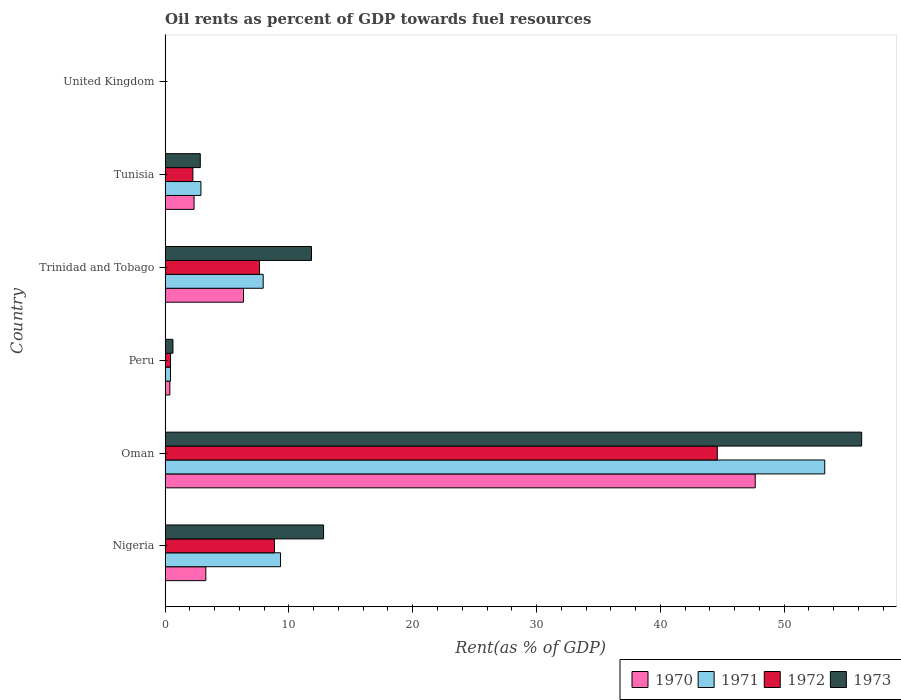How many different coloured bars are there?
Your response must be concise. 4. Are the number of bars per tick equal to the number of legend labels?
Your answer should be very brief. Yes. Are the number of bars on each tick of the Y-axis equal?
Provide a succinct answer. Yes. How many bars are there on the 1st tick from the bottom?
Keep it short and to the point. 4. What is the label of the 6th group of bars from the top?
Your answer should be compact. Nigeria. What is the oil rent in 1971 in Trinidad and Tobago?
Offer a terse response. 7.92. Across all countries, what is the maximum oil rent in 1970?
Give a very brief answer. 47.66. Across all countries, what is the minimum oil rent in 1973?
Offer a very short reply. 0. In which country was the oil rent in 1973 maximum?
Ensure brevity in your answer.  Oman. In which country was the oil rent in 1973 minimum?
Provide a short and direct response. United Kingdom. What is the total oil rent in 1972 in the graph?
Your answer should be compact. 63.74. What is the difference between the oil rent in 1973 in Peru and that in United Kingdom?
Provide a short and direct response. 0.63. What is the difference between the oil rent in 1971 in Tunisia and the oil rent in 1970 in Oman?
Provide a short and direct response. -44.77. What is the average oil rent in 1971 per country?
Make the answer very short. 12.31. What is the difference between the oil rent in 1973 and oil rent in 1970 in Trinidad and Tobago?
Offer a terse response. 5.49. What is the ratio of the oil rent in 1971 in Nigeria to that in Tunisia?
Provide a succinct answer. 3.22. What is the difference between the highest and the second highest oil rent in 1972?
Provide a short and direct response. 35.77. What is the difference between the highest and the lowest oil rent in 1972?
Your response must be concise. 44.6. In how many countries, is the oil rent in 1971 greater than the average oil rent in 1971 taken over all countries?
Keep it short and to the point. 1. Is it the case that in every country, the sum of the oil rent in 1973 and oil rent in 1972 is greater than the sum of oil rent in 1970 and oil rent in 1971?
Provide a short and direct response. No. What does the 1st bar from the top in Trinidad and Tobago represents?
Provide a short and direct response. 1973. Is it the case that in every country, the sum of the oil rent in 1970 and oil rent in 1973 is greater than the oil rent in 1972?
Provide a short and direct response. Yes. Are all the bars in the graph horizontal?
Offer a terse response. Yes. How many countries are there in the graph?
Make the answer very short. 6. Are the values on the major ticks of X-axis written in scientific E-notation?
Offer a very short reply. No. How are the legend labels stacked?
Provide a succinct answer. Horizontal. What is the title of the graph?
Offer a very short reply. Oil rents as percent of GDP towards fuel resources. Does "1972" appear as one of the legend labels in the graph?
Your answer should be compact. Yes. What is the label or title of the X-axis?
Your answer should be very brief. Rent(as % of GDP). What is the label or title of the Y-axis?
Offer a very short reply. Country. What is the Rent(as % of GDP) of 1970 in Nigeria?
Your answer should be very brief. 3.29. What is the Rent(as % of GDP) in 1971 in Nigeria?
Make the answer very short. 9.32. What is the Rent(as % of GDP) of 1972 in Nigeria?
Your response must be concise. 8.83. What is the Rent(as % of GDP) of 1973 in Nigeria?
Give a very brief answer. 12.8. What is the Rent(as % of GDP) in 1970 in Oman?
Keep it short and to the point. 47.66. What is the Rent(as % of GDP) of 1971 in Oman?
Your answer should be compact. 53.28. What is the Rent(as % of GDP) of 1972 in Oman?
Keep it short and to the point. 44.6. What is the Rent(as % of GDP) of 1973 in Oman?
Keep it short and to the point. 56.26. What is the Rent(as % of GDP) in 1970 in Peru?
Provide a succinct answer. 0.39. What is the Rent(as % of GDP) in 1971 in Peru?
Make the answer very short. 0.44. What is the Rent(as % of GDP) in 1972 in Peru?
Your answer should be very brief. 0.44. What is the Rent(as % of GDP) of 1973 in Peru?
Keep it short and to the point. 0.64. What is the Rent(as % of GDP) of 1970 in Trinidad and Tobago?
Provide a succinct answer. 6.33. What is the Rent(as % of GDP) of 1971 in Trinidad and Tobago?
Ensure brevity in your answer.  7.92. What is the Rent(as % of GDP) of 1972 in Trinidad and Tobago?
Offer a terse response. 7.63. What is the Rent(as % of GDP) of 1973 in Trinidad and Tobago?
Provide a succinct answer. 11.82. What is the Rent(as % of GDP) of 1970 in Tunisia?
Offer a terse response. 2.34. What is the Rent(as % of GDP) in 1971 in Tunisia?
Give a very brief answer. 2.89. What is the Rent(as % of GDP) of 1972 in Tunisia?
Provide a short and direct response. 2.25. What is the Rent(as % of GDP) in 1973 in Tunisia?
Your response must be concise. 2.84. What is the Rent(as % of GDP) of 1970 in United Kingdom?
Keep it short and to the point. 0. What is the Rent(as % of GDP) in 1971 in United Kingdom?
Your response must be concise. 0. What is the Rent(as % of GDP) of 1972 in United Kingdom?
Offer a very short reply. 0. What is the Rent(as % of GDP) of 1973 in United Kingdom?
Offer a terse response. 0. Across all countries, what is the maximum Rent(as % of GDP) of 1970?
Your response must be concise. 47.66. Across all countries, what is the maximum Rent(as % of GDP) of 1971?
Provide a short and direct response. 53.28. Across all countries, what is the maximum Rent(as % of GDP) in 1972?
Make the answer very short. 44.6. Across all countries, what is the maximum Rent(as % of GDP) in 1973?
Offer a terse response. 56.26. Across all countries, what is the minimum Rent(as % of GDP) in 1970?
Keep it short and to the point. 0. Across all countries, what is the minimum Rent(as % of GDP) of 1971?
Keep it short and to the point. 0. Across all countries, what is the minimum Rent(as % of GDP) in 1972?
Your answer should be very brief. 0. Across all countries, what is the minimum Rent(as % of GDP) of 1973?
Offer a very short reply. 0. What is the total Rent(as % of GDP) in 1970 in the graph?
Your answer should be compact. 60.01. What is the total Rent(as % of GDP) in 1971 in the graph?
Provide a short and direct response. 73.85. What is the total Rent(as % of GDP) in 1972 in the graph?
Your answer should be very brief. 63.74. What is the total Rent(as % of GDP) in 1973 in the graph?
Your response must be concise. 84.36. What is the difference between the Rent(as % of GDP) of 1970 in Nigeria and that in Oman?
Your answer should be very brief. -44.37. What is the difference between the Rent(as % of GDP) in 1971 in Nigeria and that in Oman?
Provide a short and direct response. -43.95. What is the difference between the Rent(as % of GDP) in 1972 in Nigeria and that in Oman?
Your answer should be very brief. -35.77. What is the difference between the Rent(as % of GDP) of 1973 in Nigeria and that in Oman?
Provide a succinct answer. -43.46. What is the difference between the Rent(as % of GDP) of 1970 in Nigeria and that in Peru?
Provide a succinct answer. 2.9. What is the difference between the Rent(as % of GDP) in 1971 in Nigeria and that in Peru?
Keep it short and to the point. 8.89. What is the difference between the Rent(as % of GDP) of 1972 in Nigeria and that in Peru?
Make the answer very short. 8.39. What is the difference between the Rent(as % of GDP) in 1973 in Nigeria and that in Peru?
Keep it short and to the point. 12.16. What is the difference between the Rent(as % of GDP) in 1970 in Nigeria and that in Trinidad and Tobago?
Your answer should be very brief. -3.04. What is the difference between the Rent(as % of GDP) of 1971 in Nigeria and that in Trinidad and Tobago?
Offer a very short reply. 1.4. What is the difference between the Rent(as % of GDP) of 1972 in Nigeria and that in Trinidad and Tobago?
Your answer should be compact. 1.2. What is the difference between the Rent(as % of GDP) of 1973 in Nigeria and that in Trinidad and Tobago?
Your answer should be compact. 0.98. What is the difference between the Rent(as % of GDP) of 1970 in Nigeria and that in Tunisia?
Your response must be concise. 0.95. What is the difference between the Rent(as % of GDP) of 1971 in Nigeria and that in Tunisia?
Your answer should be compact. 6.43. What is the difference between the Rent(as % of GDP) in 1972 in Nigeria and that in Tunisia?
Your response must be concise. 6.58. What is the difference between the Rent(as % of GDP) of 1973 in Nigeria and that in Tunisia?
Make the answer very short. 9.96. What is the difference between the Rent(as % of GDP) of 1970 in Nigeria and that in United Kingdom?
Your answer should be compact. 3.29. What is the difference between the Rent(as % of GDP) of 1971 in Nigeria and that in United Kingdom?
Your answer should be very brief. 9.32. What is the difference between the Rent(as % of GDP) in 1972 in Nigeria and that in United Kingdom?
Provide a succinct answer. 8.83. What is the difference between the Rent(as % of GDP) of 1973 in Nigeria and that in United Kingdom?
Offer a terse response. 12.8. What is the difference between the Rent(as % of GDP) of 1970 in Oman and that in Peru?
Your answer should be very brief. 47.28. What is the difference between the Rent(as % of GDP) in 1971 in Oman and that in Peru?
Your answer should be very brief. 52.84. What is the difference between the Rent(as % of GDP) of 1972 in Oman and that in Peru?
Provide a short and direct response. 44.16. What is the difference between the Rent(as % of GDP) in 1973 in Oman and that in Peru?
Your answer should be very brief. 55.62. What is the difference between the Rent(as % of GDP) of 1970 in Oman and that in Trinidad and Tobago?
Ensure brevity in your answer.  41.33. What is the difference between the Rent(as % of GDP) of 1971 in Oman and that in Trinidad and Tobago?
Your answer should be compact. 45.35. What is the difference between the Rent(as % of GDP) of 1972 in Oman and that in Trinidad and Tobago?
Keep it short and to the point. 36.97. What is the difference between the Rent(as % of GDP) of 1973 in Oman and that in Trinidad and Tobago?
Provide a succinct answer. 44.44. What is the difference between the Rent(as % of GDP) in 1970 in Oman and that in Tunisia?
Your answer should be compact. 45.32. What is the difference between the Rent(as % of GDP) of 1971 in Oman and that in Tunisia?
Your answer should be compact. 50.38. What is the difference between the Rent(as % of GDP) of 1972 in Oman and that in Tunisia?
Offer a terse response. 42.36. What is the difference between the Rent(as % of GDP) in 1973 in Oman and that in Tunisia?
Provide a succinct answer. 53.42. What is the difference between the Rent(as % of GDP) of 1970 in Oman and that in United Kingdom?
Your answer should be compact. 47.66. What is the difference between the Rent(as % of GDP) in 1971 in Oman and that in United Kingdom?
Offer a terse response. 53.28. What is the difference between the Rent(as % of GDP) in 1972 in Oman and that in United Kingdom?
Provide a short and direct response. 44.6. What is the difference between the Rent(as % of GDP) in 1973 in Oman and that in United Kingdom?
Offer a terse response. 56.26. What is the difference between the Rent(as % of GDP) in 1970 in Peru and that in Trinidad and Tobago?
Your response must be concise. -5.95. What is the difference between the Rent(as % of GDP) of 1971 in Peru and that in Trinidad and Tobago?
Give a very brief answer. -7.49. What is the difference between the Rent(as % of GDP) in 1972 in Peru and that in Trinidad and Tobago?
Offer a terse response. -7.19. What is the difference between the Rent(as % of GDP) in 1973 in Peru and that in Trinidad and Tobago?
Give a very brief answer. -11.19. What is the difference between the Rent(as % of GDP) in 1970 in Peru and that in Tunisia?
Give a very brief answer. -1.95. What is the difference between the Rent(as % of GDP) in 1971 in Peru and that in Tunisia?
Offer a terse response. -2.46. What is the difference between the Rent(as % of GDP) in 1972 in Peru and that in Tunisia?
Provide a succinct answer. -1.81. What is the difference between the Rent(as % of GDP) of 1973 in Peru and that in Tunisia?
Keep it short and to the point. -2.21. What is the difference between the Rent(as % of GDP) of 1970 in Peru and that in United Kingdom?
Offer a very short reply. 0.38. What is the difference between the Rent(as % of GDP) of 1971 in Peru and that in United Kingdom?
Provide a short and direct response. 0.44. What is the difference between the Rent(as % of GDP) in 1972 in Peru and that in United Kingdom?
Give a very brief answer. 0.44. What is the difference between the Rent(as % of GDP) in 1973 in Peru and that in United Kingdom?
Your answer should be compact. 0.63. What is the difference between the Rent(as % of GDP) of 1970 in Trinidad and Tobago and that in Tunisia?
Your answer should be very brief. 3.99. What is the difference between the Rent(as % of GDP) of 1971 in Trinidad and Tobago and that in Tunisia?
Offer a terse response. 5.03. What is the difference between the Rent(as % of GDP) of 1972 in Trinidad and Tobago and that in Tunisia?
Provide a short and direct response. 5.38. What is the difference between the Rent(as % of GDP) of 1973 in Trinidad and Tobago and that in Tunisia?
Offer a very short reply. 8.98. What is the difference between the Rent(as % of GDP) of 1970 in Trinidad and Tobago and that in United Kingdom?
Your answer should be very brief. 6.33. What is the difference between the Rent(as % of GDP) of 1971 in Trinidad and Tobago and that in United Kingdom?
Offer a terse response. 7.92. What is the difference between the Rent(as % of GDP) in 1972 in Trinidad and Tobago and that in United Kingdom?
Your answer should be very brief. 7.62. What is the difference between the Rent(as % of GDP) in 1973 in Trinidad and Tobago and that in United Kingdom?
Your response must be concise. 11.82. What is the difference between the Rent(as % of GDP) of 1970 in Tunisia and that in United Kingdom?
Your answer should be compact. 2.34. What is the difference between the Rent(as % of GDP) in 1971 in Tunisia and that in United Kingdom?
Offer a terse response. 2.89. What is the difference between the Rent(as % of GDP) of 1972 in Tunisia and that in United Kingdom?
Provide a short and direct response. 2.24. What is the difference between the Rent(as % of GDP) in 1973 in Tunisia and that in United Kingdom?
Offer a very short reply. 2.84. What is the difference between the Rent(as % of GDP) of 1970 in Nigeria and the Rent(as % of GDP) of 1971 in Oman?
Give a very brief answer. -49.99. What is the difference between the Rent(as % of GDP) in 1970 in Nigeria and the Rent(as % of GDP) in 1972 in Oman?
Offer a very short reply. -41.31. What is the difference between the Rent(as % of GDP) of 1970 in Nigeria and the Rent(as % of GDP) of 1973 in Oman?
Your answer should be very brief. -52.97. What is the difference between the Rent(as % of GDP) of 1971 in Nigeria and the Rent(as % of GDP) of 1972 in Oman?
Your response must be concise. -35.28. What is the difference between the Rent(as % of GDP) of 1971 in Nigeria and the Rent(as % of GDP) of 1973 in Oman?
Your response must be concise. -46.94. What is the difference between the Rent(as % of GDP) in 1972 in Nigeria and the Rent(as % of GDP) in 1973 in Oman?
Your answer should be compact. -47.43. What is the difference between the Rent(as % of GDP) of 1970 in Nigeria and the Rent(as % of GDP) of 1971 in Peru?
Give a very brief answer. 2.85. What is the difference between the Rent(as % of GDP) of 1970 in Nigeria and the Rent(as % of GDP) of 1972 in Peru?
Make the answer very short. 2.85. What is the difference between the Rent(as % of GDP) in 1970 in Nigeria and the Rent(as % of GDP) in 1973 in Peru?
Ensure brevity in your answer.  2.65. What is the difference between the Rent(as % of GDP) in 1971 in Nigeria and the Rent(as % of GDP) in 1972 in Peru?
Provide a short and direct response. 8.88. What is the difference between the Rent(as % of GDP) of 1971 in Nigeria and the Rent(as % of GDP) of 1973 in Peru?
Provide a short and direct response. 8.69. What is the difference between the Rent(as % of GDP) of 1972 in Nigeria and the Rent(as % of GDP) of 1973 in Peru?
Provide a short and direct response. 8.19. What is the difference between the Rent(as % of GDP) in 1970 in Nigeria and the Rent(as % of GDP) in 1971 in Trinidad and Tobago?
Offer a very short reply. -4.63. What is the difference between the Rent(as % of GDP) in 1970 in Nigeria and the Rent(as % of GDP) in 1972 in Trinidad and Tobago?
Keep it short and to the point. -4.34. What is the difference between the Rent(as % of GDP) in 1970 in Nigeria and the Rent(as % of GDP) in 1973 in Trinidad and Tobago?
Your answer should be very brief. -8.53. What is the difference between the Rent(as % of GDP) of 1971 in Nigeria and the Rent(as % of GDP) of 1972 in Trinidad and Tobago?
Offer a terse response. 1.7. What is the difference between the Rent(as % of GDP) in 1971 in Nigeria and the Rent(as % of GDP) in 1973 in Trinidad and Tobago?
Give a very brief answer. -2.5. What is the difference between the Rent(as % of GDP) in 1972 in Nigeria and the Rent(as % of GDP) in 1973 in Trinidad and Tobago?
Ensure brevity in your answer.  -2.99. What is the difference between the Rent(as % of GDP) of 1970 in Nigeria and the Rent(as % of GDP) of 1971 in Tunisia?
Make the answer very short. 0.4. What is the difference between the Rent(as % of GDP) in 1970 in Nigeria and the Rent(as % of GDP) in 1972 in Tunisia?
Offer a very short reply. 1.04. What is the difference between the Rent(as % of GDP) of 1970 in Nigeria and the Rent(as % of GDP) of 1973 in Tunisia?
Give a very brief answer. 0.45. What is the difference between the Rent(as % of GDP) in 1971 in Nigeria and the Rent(as % of GDP) in 1972 in Tunisia?
Your answer should be very brief. 7.08. What is the difference between the Rent(as % of GDP) in 1971 in Nigeria and the Rent(as % of GDP) in 1973 in Tunisia?
Offer a terse response. 6.48. What is the difference between the Rent(as % of GDP) in 1972 in Nigeria and the Rent(as % of GDP) in 1973 in Tunisia?
Provide a short and direct response. 5.99. What is the difference between the Rent(as % of GDP) in 1970 in Nigeria and the Rent(as % of GDP) in 1971 in United Kingdom?
Your response must be concise. 3.29. What is the difference between the Rent(as % of GDP) of 1970 in Nigeria and the Rent(as % of GDP) of 1972 in United Kingdom?
Your answer should be compact. 3.29. What is the difference between the Rent(as % of GDP) in 1970 in Nigeria and the Rent(as % of GDP) in 1973 in United Kingdom?
Your response must be concise. 3.29. What is the difference between the Rent(as % of GDP) in 1971 in Nigeria and the Rent(as % of GDP) in 1972 in United Kingdom?
Provide a short and direct response. 9.32. What is the difference between the Rent(as % of GDP) of 1971 in Nigeria and the Rent(as % of GDP) of 1973 in United Kingdom?
Your response must be concise. 9.32. What is the difference between the Rent(as % of GDP) of 1972 in Nigeria and the Rent(as % of GDP) of 1973 in United Kingdom?
Your answer should be very brief. 8.83. What is the difference between the Rent(as % of GDP) of 1970 in Oman and the Rent(as % of GDP) of 1971 in Peru?
Your answer should be compact. 47.23. What is the difference between the Rent(as % of GDP) of 1970 in Oman and the Rent(as % of GDP) of 1972 in Peru?
Give a very brief answer. 47.22. What is the difference between the Rent(as % of GDP) in 1970 in Oman and the Rent(as % of GDP) in 1973 in Peru?
Your response must be concise. 47.03. What is the difference between the Rent(as % of GDP) in 1971 in Oman and the Rent(as % of GDP) in 1972 in Peru?
Keep it short and to the point. 52.84. What is the difference between the Rent(as % of GDP) of 1971 in Oman and the Rent(as % of GDP) of 1973 in Peru?
Ensure brevity in your answer.  52.64. What is the difference between the Rent(as % of GDP) of 1972 in Oman and the Rent(as % of GDP) of 1973 in Peru?
Keep it short and to the point. 43.96. What is the difference between the Rent(as % of GDP) of 1970 in Oman and the Rent(as % of GDP) of 1971 in Trinidad and Tobago?
Offer a terse response. 39.74. What is the difference between the Rent(as % of GDP) in 1970 in Oman and the Rent(as % of GDP) in 1972 in Trinidad and Tobago?
Offer a terse response. 40.04. What is the difference between the Rent(as % of GDP) in 1970 in Oman and the Rent(as % of GDP) in 1973 in Trinidad and Tobago?
Provide a succinct answer. 35.84. What is the difference between the Rent(as % of GDP) of 1971 in Oman and the Rent(as % of GDP) of 1972 in Trinidad and Tobago?
Offer a very short reply. 45.65. What is the difference between the Rent(as % of GDP) in 1971 in Oman and the Rent(as % of GDP) in 1973 in Trinidad and Tobago?
Your answer should be very brief. 41.45. What is the difference between the Rent(as % of GDP) of 1972 in Oman and the Rent(as % of GDP) of 1973 in Trinidad and Tobago?
Give a very brief answer. 32.78. What is the difference between the Rent(as % of GDP) of 1970 in Oman and the Rent(as % of GDP) of 1971 in Tunisia?
Your answer should be very brief. 44.77. What is the difference between the Rent(as % of GDP) in 1970 in Oman and the Rent(as % of GDP) in 1972 in Tunisia?
Give a very brief answer. 45.42. What is the difference between the Rent(as % of GDP) of 1970 in Oman and the Rent(as % of GDP) of 1973 in Tunisia?
Your answer should be very brief. 44.82. What is the difference between the Rent(as % of GDP) of 1971 in Oman and the Rent(as % of GDP) of 1972 in Tunisia?
Make the answer very short. 51.03. What is the difference between the Rent(as % of GDP) in 1971 in Oman and the Rent(as % of GDP) in 1973 in Tunisia?
Provide a short and direct response. 50.43. What is the difference between the Rent(as % of GDP) in 1972 in Oman and the Rent(as % of GDP) in 1973 in Tunisia?
Ensure brevity in your answer.  41.76. What is the difference between the Rent(as % of GDP) of 1970 in Oman and the Rent(as % of GDP) of 1971 in United Kingdom?
Ensure brevity in your answer.  47.66. What is the difference between the Rent(as % of GDP) of 1970 in Oman and the Rent(as % of GDP) of 1972 in United Kingdom?
Your answer should be very brief. 47.66. What is the difference between the Rent(as % of GDP) of 1970 in Oman and the Rent(as % of GDP) of 1973 in United Kingdom?
Keep it short and to the point. 47.66. What is the difference between the Rent(as % of GDP) in 1971 in Oman and the Rent(as % of GDP) in 1972 in United Kingdom?
Your response must be concise. 53.28. What is the difference between the Rent(as % of GDP) in 1971 in Oman and the Rent(as % of GDP) in 1973 in United Kingdom?
Give a very brief answer. 53.27. What is the difference between the Rent(as % of GDP) of 1972 in Oman and the Rent(as % of GDP) of 1973 in United Kingdom?
Your answer should be compact. 44.6. What is the difference between the Rent(as % of GDP) of 1970 in Peru and the Rent(as % of GDP) of 1971 in Trinidad and Tobago?
Your response must be concise. -7.54. What is the difference between the Rent(as % of GDP) in 1970 in Peru and the Rent(as % of GDP) in 1972 in Trinidad and Tobago?
Your answer should be very brief. -7.24. What is the difference between the Rent(as % of GDP) of 1970 in Peru and the Rent(as % of GDP) of 1973 in Trinidad and Tobago?
Make the answer very short. -11.44. What is the difference between the Rent(as % of GDP) of 1971 in Peru and the Rent(as % of GDP) of 1972 in Trinidad and Tobago?
Keep it short and to the point. -7.19. What is the difference between the Rent(as % of GDP) of 1971 in Peru and the Rent(as % of GDP) of 1973 in Trinidad and Tobago?
Give a very brief answer. -11.39. What is the difference between the Rent(as % of GDP) of 1972 in Peru and the Rent(as % of GDP) of 1973 in Trinidad and Tobago?
Your answer should be very brief. -11.38. What is the difference between the Rent(as % of GDP) in 1970 in Peru and the Rent(as % of GDP) in 1971 in Tunisia?
Your response must be concise. -2.51. What is the difference between the Rent(as % of GDP) in 1970 in Peru and the Rent(as % of GDP) in 1972 in Tunisia?
Your answer should be compact. -1.86. What is the difference between the Rent(as % of GDP) in 1970 in Peru and the Rent(as % of GDP) in 1973 in Tunisia?
Keep it short and to the point. -2.46. What is the difference between the Rent(as % of GDP) in 1971 in Peru and the Rent(as % of GDP) in 1972 in Tunisia?
Ensure brevity in your answer.  -1.81. What is the difference between the Rent(as % of GDP) of 1971 in Peru and the Rent(as % of GDP) of 1973 in Tunisia?
Provide a short and direct response. -2.4. What is the difference between the Rent(as % of GDP) of 1972 in Peru and the Rent(as % of GDP) of 1973 in Tunisia?
Your answer should be very brief. -2.4. What is the difference between the Rent(as % of GDP) in 1970 in Peru and the Rent(as % of GDP) in 1971 in United Kingdom?
Your answer should be compact. 0.38. What is the difference between the Rent(as % of GDP) in 1970 in Peru and the Rent(as % of GDP) in 1972 in United Kingdom?
Provide a short and direct response. 0.38. What is the difference between the Rent(as % of GDP) of 1970 in Peru and the Rent(as % of GDP) of 1973 in United Kingdom?
Your answer should be compact. 0.38. What is the difference between the Rent(as % of GDP) in 1971 in Peru and the Rent(as % of GDP) in 1972 in United Kingdom?
Provide a succinct answer. 0.44. What is the difference between the Rent(as % of GDP) in 1971 in Peru and the Rent(as % of GDP) in 1973 in United Kingdom?
Your answer should be compact. 0.43. What is the difference between the Rent(as % of GDP) of 1972 in Peru and the Rent(as % of GDP) of 1973 in United Kingdom?
Provide a short and direct response. 0.44. What is the difference between the Rent(as % of GDP) in 1970 in Trinidad and Tobago and the Rent(as % of GDP) in 1971 in Tunisia?
Your answer should be compact. 3.44. What is the difference between the Rent(as % of GDP) in 1970 in Trinidad and Tobago and the Rent(as % of GDP) in 1972 in Tunisia?
Provide a short and direct response. 4.09. What is the difference between the Rent(as % of GDP) in 1970 in Trinidad and Tobago and the Rent(as % of GDP) in 1973 in Tunisia?
Provide a short and direct response. 3.49. What is the difference between the Rent(as % of GDP) of 1971 in Trinidad and Tobago and the Rent(as % of GDP) of 1972 in Tunisia?
Provide a short and direct response. 5.68. What is the difference between the Rent(as % of GDP) in 1971 in Trinidad and Tobago and the Rent(as % of GDP) in 1973 in Tunisia?
Provide a succinct answer. 5.08. What is the difference between the Rent(as % of GDP) of 1972 in Trinidad and Tobago and the Rent(as % of GDP) of 1973 in Tunisia?
Give a very brief answer. 4.78. What is the difference between the Rent(as % of GDP) in 1970 in Trinidad and Tobago and the Rent(as % of GDP) in 1971 in United Kingdom?
Keep it short and to the point. 6.33. What is the difference between the Rent(as % of GDP) in 1970 in Trinidad and Tobago and the Rent(as % of GDP) in 1972 in United Kingdom?
Provide a succinct answer. 6.33. What is the difference between the Rent(as % of GDP) of 1970 in Trinidad and Tobago and the Rent(as % of GDP) of 1973 in United Kingdom?
Your answer should be compact. 6.33. What is the difference between the Rent(as % of GDP) in 1971 in Trinidad and Tobago and the Rent(as % of GDP) in 1972 in United Kingdom?
Make the answer very short. 7.92. What is the difference between the Rent(as % of GDP) of 1971 in Trinidad and Tobago and the Rent(as % of GDP) of 1973 in United Kingdom?
Provide a succinct answer. 7.92. What is the difference between the Rent(as % of GDP) of 1972 in Trinidad and Tobago and the Rent(as % of GDP) of 1973 in United Kingdom?
Ensure brevity in your answer.  7.62. What is the difference between the Rent(as % of GDP) in 1970 in Tunisia and the Rent(as % of GDP) in 1971 in United Kingdom?
Your answer should be compact. 2.34. What is the difference between the Rent(as % of GDP) of 1970 in Tunisia and the Rent(as % of GDP) of 1972 in United Kingdom?
Provide a short and direct response. 2.34. What is the difference between the Rent(as % of GDP) in 1970 in Tunisia and the Rent(as % of GDP) in 1973 in United Kingdom?
Offer a very short reply. 2.34. What is the difference between the Rent(as % of GDP) in 1971 in Tunisia and the Rent(as % of GDP) in 1972 in United Kingdom?
Provide a short and direct response. 2.89. What is the difference between the Rent(as % of GDP) in 1971 in Tunisia and the Rent(as % of GDP) in 1973 in United Kingdom?
Your response must be concise. 2.89. What is the difference between the Rent(as % of GDP) in 1972 in Tunisia and the Rent(as % of GDP) in 1973 in United Kingdom?
Your answer should be very brief. 2.24. What is the average Rent(as % of GDP) in 1970 per country?
Offer a very short reply. 10. What is the average Rent(as % of GDP) in 1971 per country?
Offer a very short reply. 12.31. What is the average Rent(as % of GDP) of 1972 per country?
Keep it short and to the point. 10.62. What is the average Rent(as % of GDP) of 1973 per country?
Provide a short and direct response. 14.06. What is the difference between the Rent(as % of GDP) in 1970 and Rent(as % of GDP) in 1971 in Nigeria?
Offer a very short reply. -6.03. What is the difference between the Rent(as % of GDP) in 1970 and Rent(as % of GDP) in 1972 in Nigeria?
Give a very brief answer. -5.54. What is the difference between the Rent(as % of GDP) of 1970 and Rent(as % of GDP) of 1973 in Nigeria?
Your response must be concise. -9.51. What is the difference between the Rent(as % of GDP) in 1971 and Rent(as % of GDP) in 1972 in Nigeria?
Offer a terse response. 0.49. What is the difference between the Rent(as % of GDP) in 1971 and Rent(as % of GDP) in 1973 in Nigeria?
Ensure brevity in your answer.  -3.48. What is the difference between the Rent(as % of GDP) of 1972 and Rent(as % of GDP) of 1973 in Nigeria?
Your answer should be very brief. -3.97. What is the difference between the Rent(as % of GDP) in 1970 and Rent(as % of GDP) in 1971 in Oman?
Offer a very short reply. -5.61. What is the difference between the Rent(as % of GDP) in 1970 and Rent(as % of GDP) in 1972 in Oman?
Provide a short and direct response. 3.06. What is the difference between the Rent(as % of GDP) in 1970 and Rent(as % of GDP) in 1973 in Oman?
Your answer should be compact. -8.6. What is the difference between the Rent(as % of GDP) in 1971 and Rent(as % of GDP) in 1972 in Oman?
Provide a succinct answer. 8.68. What is the difference between the Rent(as % of GDP) in 1971 and Rent(as % of GDP) in 1973 in Oman?
Give a very brief answer. -2.98. What is the difference between the Rent(as % of GDP) in 1972 and Rent(as % of GDP) in 1973 in Oman?
Your answer should be compact. -11.66. What is the difference between the Rent(as % of GDP) of 1970 and Rent(as % of GDP) of 1971 in Peru?
Ensure brevity in your answer.  -0.05. What is the difference between the Rent(as % of GDP) in 1970 and Rent(as % of GDP) in 1972 in Peru?
Give a very brief answer. -0.05. What is the difference between the Rent(as % of GDP) of 1970 and Rent(as % of GDP) of 1973 in Peru?
Make the answer very short. -0.25. What is the difference between the Rent(as % of GDP) in 1971 and Rent(as % of GDP) in 1972 in Peru?
Provide a succinct answer. -0. What is the difference between the Rent(as % of GDP) of 1971 and Rent(as % of GDP) of 1973 in Peru?
Offer a very short reply. -0.2. What is the difference between the Rent(as % of GDP) of 1972 and Rent(as % of GDP) of 1973 in Peru?
Provide a short and direct response. -0.2. What is the difference between the Rent(as % of GDP) in 1970 and Rent(as % of GDP) in 1971 in Trinidad and Tobago?
Keep it short and to the point. -1.59. What is the difference between the Rent(as % of GDP) of 1970 and Rent(as % of GDP) of 1972 in Trinidad and Tobago?
Provide a succinct answer. -1.29. What is the difference between the Rent(as % of GDP) in 1970 and Rent(as % of GDP) in 1973 in Trinidad and Tobago?
Offer a terse response. -5.49. What is the difference between the Rent(as % of GDP) in 1971 and Rent(as % of GDP) in 1972 in Trinidad and Tobago?
Make the answer very short. 0.3. What is the difference between the Rent(as % of GDP) in 1971 and Rent(as % of GDP) in 1973 in Trinidad and Tobago?
Your answer should be compact. -3.9. What is the difference between the Rent(as % of GDP) of 1972 and Rent(as % of GDP) of 1973 in Trinidad and Tobago?
Offer a terse response. -4.2. What is the difference between the Rent(as % of GDP) of 1970 and Rent(as % of GDP) of 1971 in Tunisia?
Give a very brief answer. -0.55. What is the difference between the Rent(as % of GDP) of 1970 and Rent(as % of GDP) of 1972 in Tunisia?
Provide a succinct answer. 0.1. What is the difference between the Rent(as % of GDP) of 1970 and Rent(as % of GDP) of 1973 in Tunisia?
Ensure brevity in your answer.  -0.5. What is the difference between the Rent(as % of GDP) in 1971 and Rent(as % of GDP) in 1972 in Tunisia?
Make the answer very short. 0.65. What is the difference between the Rent(as % of GDP) of 1971 and Rent(as % of GDP) of 1973 in Tunisia?
Your response must be concise. 0.05. What is the difference between the Rent(as % of GDP) in 1972 and Rent(as % of GDP) in 1973 in Tunisia?
Provide a succinct answer. -0.6. What is the difference between the Rent(as % of GDP) of 1970 and Rent(as % of GDP) of 1972 in United Kingdom?
Your answer should be very brief. -0. What is the difference between the Rent(as % of GDP) in 1970 and Rent(as % of GDP) in 1973 in United Kingdom?
Ensure brevity in your answer.  -0. What is the difference between the Rent(as % of GDP) of 1971 and Rent(as % of GDP) of 1972 in United Kingdom?
Your answer should be very brief. -0. What is the difference between the Rent(as % of GDP) of 1971 and Rent(as % of GDP) of 1973 in United Kingdom?
Give a very brief answer. -0. What is the difference between the Rent(as % of GDP) of 1972 and Rent(as % of GDP) of 1973 in United Kingdom?
Your answer should be very brief. -0. What is the ratio of the Rent(as % of GDP) of 1970 in Nigeria to that in Oman?
Offer a very short reply. 0.07. What is the ratio of the Rent(as % of GDP) in 1971 in Nigeria to that in Oman?
Your answer should be very brief. 0.17. What is the ratio of the Rent(as % of GDP) of 1972 in Nigeria to that in Oman?
Give a very brief answer. 0.2. What is the ratio of the Rent(as % of GDP) in 1973 in Nigeria to that in Oman?
Your answer should be compact. 0.23. What is the ratio of the Rent(as % of GDP) in 1970 in Nigeria to that in Peru?
Provide a short and direct response. 8.53. What is the ratio of the Rent(as % of GDP) in 1971 in Nigeria to that in Peru?
Make the answer very short. 21.35. What is the ratio of the Rent(as % of GDP) of 1972 in Nigeria to that in Peru?
Offer a very short reply. 20.12. What is the ratio of the Rent(as % of GDP) of 1973 in Nigeria to that in Peru?
Give a very brief answer. 20.13. What is the ratio of the Rent(as % of GDP) of 1970 in Nigeria to that in Trinidad and Tobago?
Your response must be concise. 0.52. What is the ratio of the Rent(as % of GDP) of 1971 in Nigeria to that in Trinidad and Tobago?
Provide a short and direct response. 1.18. What is the ratio of the Rent(as % of GDP) in 1972 in Nigeria to that in Trinidad and Tobago?
Provide a succinct answer. 1.16. What is the ratio of the Rent(as % of GDP) in 1973 in Nigeria to that in Trinidad and Tobago?
Your answer should be compact. 1.08. What is the ratio of the Rent(as % of GDP) in 1970 in Nigeria to that in Tunisia?
Give a very brief answer. 1.41. What is the ratio of the Rent(as % of GDP) of 1971 in Nigeria to that in Tunisia?
Offer a very short reply. 3.22. What is the ratio of the Rent(as % of GDP) of 1972 in Nigeria to that in Tunisia?
Your answer should be compact. 3.93. What is the ratio of the Rent(as % of GDP) in 1973 in Nigeria to that in Tunisia?
Your answer should be compact. 4.5. What is the ratio of the Rent(as % of GDP) in 1970 in Nigeria to that in United Kingdom?
Your response must be concise. 3714.35. What is the ratio of the Rent(as % of GDP) of 1971 in Nigeria to that in United Kingdom?
Ensure brevity in your answer.  1.32e+04. What is the ratio of the Rent(as % of GDP) of 1972 in Nigeria to that in United Kingdom?
Your answer should be compact. 6825.07. What is the ratio of the Rent(as % of GDP) of 1973 in Nigeria to that in United Kingdom?
Your response must be concise. 5703.97. What is the ratio of the Rent(as % of GDP) of 1970 in Oman to that in Peru?
Provide a succinct answer. 123.65. What is the ratio of the Rent(as % of GDP) in 1971 in Oman to that in Peru?
Your answer should be very brief. 121.98. What is the ratio of the Rent(as % of GDP) of 1972 in Oman to that in Peru?
Your answer should be very brief. 101.64. What is the ratio of the Rent(as % of GDP) in 1973 in Oman to that in Peru?
Offer a very short reply. 88.49. What is the ratio of the Rent(as % of GDP) of 1970 in Oman to that in Trinidad and Tobago?
Offer a very short reply. 7.52. What is the ratio of the Rent(as % of GDP) of 1971 in Oman to that in Trinidad and Tobago?
Give a very brief answer. 6.73. What is the ratio of the Rent(as % of GDP) of 1972 in Oman to that in Trinidad and Tobago?
Your answer should be very brief. 5.85. What is the ratio of the Rent(as % of GDP) in 1973 in Oman to that in Trinidad and Tobago?
Provide a short and direct response. 4.76. What is the ratio of the Rent(as % of GDP) of 1970 in Oman to that in Tunisia?
Offer a very short reply. 20.37. What is the ratio of the Rent(as % of GDP) of 1971 in Oman to that in Tunisia?
Give a very brief answer. 18.41. What is the ratio of the Rent(as % of GDP) of 1972 in Oman to that in Tunisia?
Give a very brief answer. 19.87. What is the ratio of the Rent(as % of GDP) of 1973 in Oman to that in Tunisia?
Offer a very short reply. 19.8. What is the ratio of the Rent(as % of GDP) of 1970 in Oman to that in United Kingdom?
Provide a succinct answer. 5.38e+04. What is the ratio of the Rent(as % of GDP) of 1971 in Oman to that in United Kingdom?
Ensure brevity in your answer.  7.53e+04. What is the ratio of the Rent(as % of GDP) of 1972 in Oman to that in United Kingdom?
Provide a short and direct response. 3.45e+04. What is the ratio of the Rent(as % of GDP) of 1973 in Oman to that in United Kingdom?
Make the answer very short. 2.51e+04. What is the ratio of the Rent(as % of GDP) of 1970 in Peru to that in Trinidad and Tobago?
Provide a short and direct response. 0.06. What is the ratio of the Rent(as % of GDP) of 1971 in Peru to that in Trinidad and Tobago?
Your response must be concise. 0.06. What is the ratio of the Rent(as % of GDP) of 1972 in Peru to that in Trinidad and Tobago?
Offer a very short reply. 0.06. What is the ratio of the Rent(as % of GDP) of 1973 in Peru to that in Trinidad and Tobago?
Ensure brevity in your answer.  0.05. What is the ratio of the Rent(as % of GDP) of 1970 in Peru to that in Tunisia?
Provide a short and direct response. 0.16. What is the ratio of the Rent(as % of GDP) in 1971 in Peru to that in Tunisia?
Provide a succinct answer. 0.15. What is the ratio of the Rent(as % of GDP) in 1972 in Peru to that in Tunisia?
Your response must be concise. 0.2. What is the ratio of the Rent(as % of GDP) in 1973 in Peru to that in Tunisia?
Keep it short and to the point. 0.22. What is the ratio of the Rent(as % of GDP) in 1970 in Peru to that in United Kingdom?
Ensure brevity in your answer.  435.22. What is the ratio of the Rent(as % of GDP) of 1971 in Peru to that in United Kingdom?
Make the answer very short. 617.08. What is the ratio of the Rent(as % of GDP) in 1972 in Peru to that in United Kingdom?
Provide a short and direct response. 339.21. What is the ratio of the Rent(as % of GDP) of 1973 in Peru to that in United Kingdom?
Your answer should be very brief. 283.34. What is the ratio of the Rent(as % of GDP) of 1970 in Trinidad and Tobago to that in Tunisia?
Provide a short and direct response. 2.71. What is the ratio of the Rent(as % of GDP) in 1971 in Trinidad and Tobago to that in Tunisia?
Ensure brevity in your answer.  2.74. What is the ratio of the Rent(as % of GDP) of 1972 in Trinidad and Tobago to that in Tunisia?
Ensure brevity in your answer.  3.4. What is the ratio of the Rent(as % of GDP) of 1973 in Trinidad and Tobago to that in Tunisia?
Ensure brevity in your answer.  4.16. What is the ratio of the Rent(as % of GDP) of 1970 in Trinidad and Tobago to that in United Kingdom?
Your answer should be compact. 7151.98. What is the ratio of the Rent(as % of GDP) in 1971 in Trinidad and Tobago to that in United Kingdom?
Offer a very short reply. 1.12e+04. What is the ratio of the Rent(as % of GDP) of 1972 in Trinidad and Tobago to that in United Kingdom?
Make the answer very short. 5894.4. What is the ratio of the Rent(as % of GDP) in 1973 in Trinidad and Tobago to that in United Kingdom?
Your answer should be compact. 5268.85. What is the ratio of the Rent(as % of GDP) of 1970 in Tunisia to that in United Kingdom?
Your response must be concise. 2642.42. What is the ratio of the Rent(as % of GDP) of 1971 in Tunisia to that in United Kingdom?
Give a very brief answer. 4088.61. What is the ratio of the Rent(as % of GDP) of 1972 in Tunisia to that in United Kingdom?
Your answer should be very brief. 1735.44. What is the ratio of the Rent(as % of GDP) of 1973 in Tunisia to that in United Kingdom?
Your answer should be very brief. 1266.39. What is the difference between the highest and the second highest Rent(as % of GDP) of 1970?
Offer a very short reply. 41.33. What is the difference between the highest and the second highest Rent(as % of GDP) of 1971?
Offer a terse response. 43.95. What is the difference between the highest and the second highest Rent(as % of GDP) in 1972?
Keep it short and to the point. 35.77. What is the difference between the highest and the second highest Rent(as % of GDP) in 1973?
Make the answer very short. 43.46. What is the difference between the highest and the lowest Rent(as % of GDP) of 1970?
Provide a short and direct response. 47.66. What is the difference between the highest and the lowest Rent(as % of GDP) of 1971?
Give a very brief answer. 53.28. What is the difference between the highest and the lowest Rent(as % of GDP) in 1972?
Your response must be concise. 44.6. What is the difference between the highest and the lowest Rent(as % of GDP) of 1973?
Offer a terse response. 56.26. 